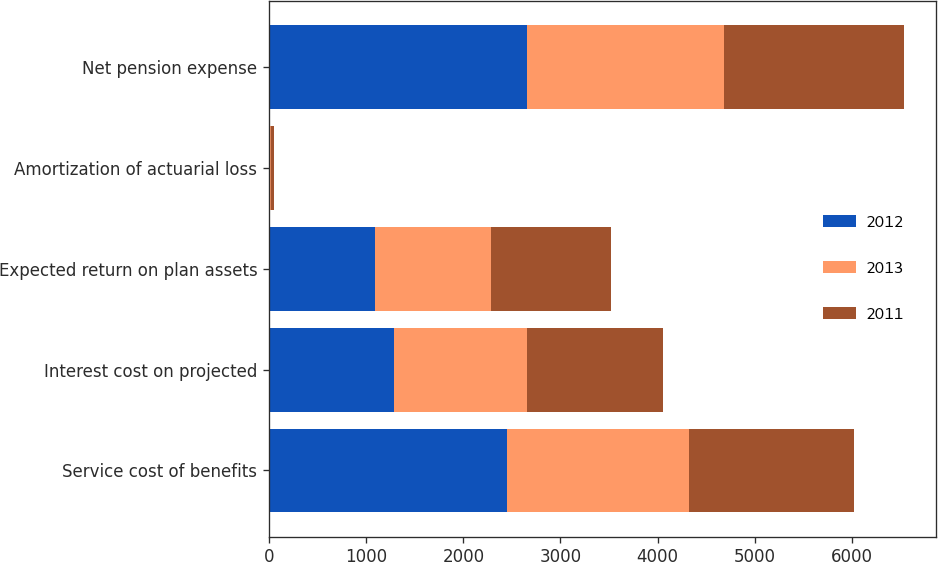<chart> <loc_0><loc_0><loc_500><loc_500><stacked_bar_chart><ecel><fcel>Service cost of benefits<fcel>Interest cost on projected<fcel>Expected return on plan assets<fcel>Amortization of actuarial loss<fcel>Net pension expense<nl><fcel>2012<fcel>2450<fcel>1285<fcel>1094<fcel>13<fcel>2654<nl><fcel>2013<fcel>1870<fcel>1367<fcel>1192<fcel>10<fcel>2035<nl><fcel>2011<fcel>1708<fcel>1400<fcel>1232<fcel>26<fcel>1850<nl></chart> 